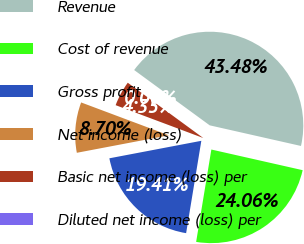<chart> <loc_0><loc_0><loc_500><loc_500><pie_chart><fcel>Revenue<fcel>Cost of revenue<fcel>Gross profit<fcel>Net income (loss)<fcel>Basic net income (loss) per<fcel>Diluted net income (loss) per<nl><fcel>43.48%<fcel>24.06%<fcel>19.41%<fcel>8.7%<fcel>4.35%<fcel>0.0%<nl></chart> 